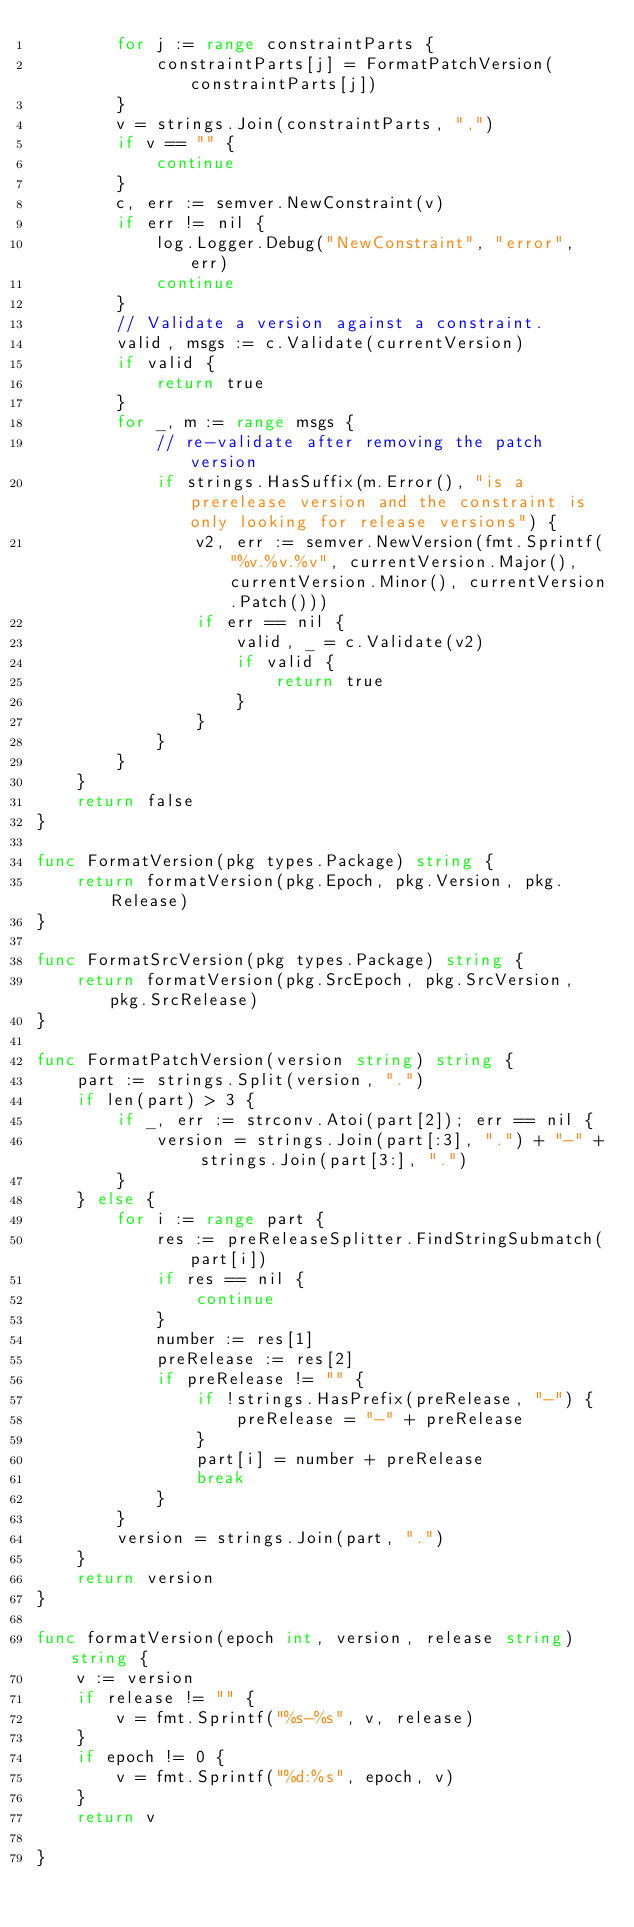Convert code to text. <code><loc_0><loc_0><loc_500><loc_500><_Go_>		for j := range constraintParts {
			constraintParts[j] = FormatPatchVersion(constraintParts[j])
		}
		v = strings.Join(constraintParts, ",")
		if v == "" {
			continue
		}
		c, err := semver.NewConstraint(v)
		if err != nil {
			log.Logger.Debug("NewConstraint", "error", err)
			continue
		}
		// Validate a version against a constraint.
		valid, msgs := c.Validate(currentVersion)
		if valid {
			return true
		}
		for _, m := range msgs {
			// re-validate after removing the patch version
			if strings.HasSuffix(m.Error(), "is a prerelease version and the constraint is only looking for release versions") {
				v2, err := semver.NewVersion(fmt.Sprintf("%v.%v.%v", currentVersion.Major(), currentVersion.Minor(), currentVersion.Patch()))
				if err == nil {
					valid, _ = c.Validate(v2)
					if valid {
						return true
					}
				}
			}
		}
	}
	return false
}

func FormatVersion(pkg types.Package) string {
	return formatVersion(pkg.Epoch, pkg.Version, pkg.Release)
}

func FormatSrcVersion(pkg types.Package) string {
	return formatVersion(pkg.SrcEpoch, pkg.SrcVersion, pkg.SrcRelease)
}

func FormatPatchVersion(version string) string {
	part := strings.Split(version, ".")
	if len(part) > 3 {
		if _, err := strconv.Atoi(part[2]); err == nil {
			version = strings.Join(part[:3], ".") + "-" + strings.Join(part[3:], ".")
		}
	} else {
		for i := range part {
			res := preReleaseSplitter.FindStringSubmatch(part[i])
			if res == nil {
				continue
			}
			number := res[1]
			preRelease := res[2]
			if preRelease != "" {
				if !strings.HasPrefix(preRelease, "-") {
					preRelease = "-" + preRelease
				}
				part[i] = number + preRelease
				break
			}
		}
		version = strings.Join(part, ".")
	}
	return version
}

func formatVersion(epoch int, version, release string) string {
	v := version
	if release != "" {
		v = fmt.Sprintf("%s-%s", v, release)
	}
	if epoch != 0 {
		v = fmt.Sprintf("%d:%s", epoch, v)
	}
	return v

}
</code> 